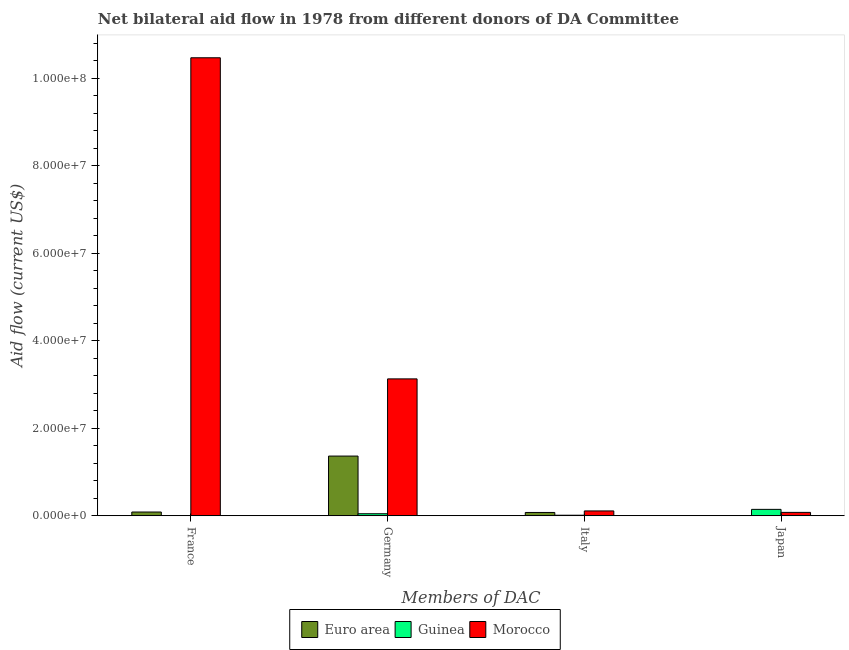How many different coloured bars are there?
Your answer should be very brief. 3. How many groups of bars are there?
Keep it short and to the point. 4. Are the number of bars per tick equal to the number of legend labels?
Make the answer very short. No. How many bars are there on the 2nd tick from the right?
Provide a short and direct response. 3. What is the label of the 3rd group of bars from the left?
Give a very brief answer. Italy. What is the amount of aid given by italy in Morocco?
Keep it short and to the point. 1.11e+06. Across all countries, what is the maximum amount of aid given by japan?
Ensure brevity in your answer.  1.47e+06. Across all countries, what is the minimum amount of aid given by italy?
Ensure brevity in your answer.  1.30e+05. In which country was the amount of aid given by germany maximum?
Offer a very short reply. Morocco. What is the total amount of aid given by italy in the graph?
Keep it short and to the point. 2.00e+06. What is the difference between the amount of aid given by germany in Euro area and that in Guinea?
Your answer should be compact. 1.32e+07. What is the difference between the amount of aid given by germany in Guinea and the amount of aid given by france in Morocco?
Ensure brevity in your answer.  -1.04e+08. What is the average amount of aid given by france per country?
Provide a succinct answer. 3.52e+07. What is the difference between the amount of aid given by italy and amount of aid given by germany in Morocco?
Make the answer very short. -3.02e+07. In how many countries, is the amount of aid given by france greater than 52000000 US$?
Make the answer very short. 1. What is the ratio of the amount of aid given by germany in Guinea to that in Euro area?
Your answer should be compact. 0.03. Is the amount of aid given by germany in Morocco less than that in Guinea?
Give a very brief answer. No. What is the difference between the highest and the second highest amount of aid given by japan?
Your response must be concise. 6.90e+05. What is the difference between the highest and the lowest amount of aid given by japan?
Offer a terse response. 1.44e+06. In how many countries, is the amount of aid given by italy greater than the average amount of aid given by italy taken over all countries?
Offer a very short reply. 2. Is it the case that in every country, the sum of the amount of aid given by france and amount of aid given by germany is greater than the amount of aid given by italy?
Offer a terse response. Yes. Are the values on the major ticks of Y-axis written in scientific E-notation?
Your answer should be very brief. Yes. How many legend labels are there?
Ensure brevity in your answer.  3. How are the legend labels stacked?
Your answer should be very brief. Horizontal. What is the title of the graph?
Your answer should be very brief. Net bilateral aid flow in 1978 from different donors of DA Committee. Does "Uganda" appear as one of the legend labels in the graph?
Your answer should be very brief. No. What is the label or title of the X-axis?
Make the answer very short. Members of DAC. What is the label or title of the Y-axis?
Provide a short and direct response. Aid flow (current US$). What is the Aid flow (current US$) in Euro area in France?
Your response must be concise. 8.60e+05. What is the Aid flow (current US$) in Guinea in France?
Provide a short and direct response. 0. What is the Aid flow (current US$) of Morocco in France?
Keep it short and to the point. 1.05e+08. What is the Aid flow (current US$) in Euro area in Germany?
Provide a short and direct response. 1.36e+07. What is the Aid flow (current US$) of Morocco in Germany?
Make the answer very short. 3.13e+07. What is the Aid flow (current US$) of Euro area in Italy?
Provide a succinct answer. 7.60e+05. What is the Aid flow (current US$) of Morocco in Italy?
Give a very brief answer. 1.11e+06. What is the Aid flow (current US$) in Euro area in Japan?
Offer a very short reply. 3.00e+04. What is the Aid flow (current US$) of Guinea in Japan?
Ensure brevity in your answer.  1.47e+06. What is the Aid flow (current US$) of Morocco in Japan?
Offer a terse response. 7.80e+05. Across all Members of DAC, what is the maximum Aid flow (current US$) of Euro area?
Your answer should be compact. 1.36e+07. Across all Members of DAC, what is the maximum Aid flow (current US$) of Guinea?
Offer a very short reply. 1.47e+06. Across all Members of DAC, what is the maximum Aid flow (current US$) in Morocco?
Provide a short and direct response. 1.05e+08. Across all Members of DAC, what is the minimum Aid flow (current US$) of Morocco?
Make the answer very short. 7.80e+05. What is the total Aid flow (current US$) of Euro area in the graph?
Make the answer very short. 1.53e+07. What is the total Aid flow (current US$) of Guinea in the graph?
Your response must be concise. 2.07e+06. What is the total Aid flow (current US$) in Morocco in the graph?
Provide a succinct answer. 1.38e+08. What is the difference between the Aid flow (current US$) of Euro area in France and that in Germany?
Offer a very short reply. -1.28e+07. What is the difference between the Aid flow (current US$) of Morocco in France and that in Germany?
Keep it short and to the point. 7.34e+07. What is the difference between the Aid flow (current US$) of Euro area in France and that in Italy?
Keep it short and to the point. 1.00e+05. What is the difference between the Aid flow (current US$) of Morocco in France and that in Italy?
Offer a very short reply. 1.04e+08. What is the difference between the Aid flow (current US$) of Euro area in France and that in Japan?
Keep it short and to the point. 8.30e+05. What is the difference between the Aid flow (current US$) in Morocco in France and that in Japan?
Give a very brief answer. 1.04e+08. What is the difference between the Aid flow (current US$) in Euro area in Germany and that in Italy?
Keep it short and to the point. 1.29e+07. What is the difference between the Aid flow (current US$) in Morocco in Germany and that in Italy?
Provide a succinct answer. 3.02e+07. What is the difference between the Aid flow (current US$) of Euro area in Germany and that in Japan?
Your answer should be very brief. 1.36e+07. What is the difference between the Aid flow (current US$) in Morocco in Germany and that in Japan?
Offer a very short reply. 3.05e+07. What is the difference between the Aid flow (current US$) of Euro area in Italy and that in Japan?
Give a very brief answer. 7.30e+05. What is the difference between the Aid flow (current US$) of Guinea in Italy and that in Japan?
Offer a terse response. -1.34e+06. What is the difference between the Aid flow (current US$) of Morocco in Italy and that in Japan?
Ensure brevity in your answer.  3.30e+05. What is the difference between the Aid flow (current US$) of Euro area in France and the Aid flow (current US$) of Morocco in Germany?
Ensure brevity in your answer.  -3.04e+07. What is the difference between the Aid flow (current US$) of Euro area in France and the Aid flow (current US$) of Guinea in Italy?
Your response must be concise. 7.30e+05. What is the difference between the Aid flow (current US$) of Euro area in France and the Aid flow (current US$) of Morocco in Italy?
Give a very brief answer. -2.50e+05. What is the difference between the Aid flow (current US$) of Euro area in France and the Aid flow (current US$) of Guinea in Japan?
Offer a terse response. -6.10e+05. What is the difference between the Aid flow (current US$) of Euro area in Germany and the Aid flow (current US$) of Guinea in Italy?
Keep it short and to the point. 1.35e+07. What is the difference between the Aid flow (current US$) in Euro area in Germany and the Aid flow (current US$) in Morocco in Italy?
Your response must be concise. 1.25e+07. What is the difference between the Aid flow (current US$) of Guinea in Germany and the Aid flow (current US$) of Morocco in Italy?
Offer a very short reply. -6.40e+05. What is the difference between the Aid flow (current US$) in Euro area in Germany and the Aid flow (current US$) in Guinea in Japan?
Make the answer very short. 1.22e+07. What is the difference between the Aid flow (current US$) in Euro area in Germany and the Aid flow (current US$) in Morocco in Japan?
Keep it short and to the point. 1.29e+07. What is the difference between the Aid flow (current US$) in Guinea in Germany and the Aid flow (current US$) in Morocco in Japan?
Keep it short and to the point. -3.10e+05. What is the difference between the Aid flow (current US$) in Euro area in Italy and the Aid flow (current US$) in Guinea in Japan?
Offer a very short reply. -7.10e+05. What is the difference between the Aid flow (current US$) in Guinea in Italy and the Aid flow (current US$) in Morocco in Japan?
Offer a very short reply. -6.50e+05. What is the average Aid flow (current US$) in Euro area per Members of DAC?
Your response must be concise. 3.82e+06. What is the average Aid flow (current US$) in Guinea per Members of DAC?
Provide a short and direct response. 5.18e+05. What is the average Aid flow (current US$) in Morocco per Members of DAC?
Offer a terse response. 3.45e+07. What is the difference between the Aid flow (current US$) in Euro area and Aid flow (current US$) in Morocco in France?
Ensure brevity in your answer.  -1.04e+08. What is the difference between the Aid flow (current US$) of Euro area and Aid flow (current US$) of Guinea in Germany?
Give a very brief answer. 1.32e+07. What is the difference between the Aid flow (current US$) of Euro area and Aid flow (current US$) of Morocco in Germany?
Keep it short and to the point. -1.76e+07. What is the difference between the Aid flow (current US$) of Guinea and Aid flow (current US$) of Morocco in Germany?
Make the answer very short. -3.08e+07. What is the difference between the Aid flow (current US$) of Euro area and Aid flow (current US$) of Guinea in Italy?
Provide a short and direct response. 6.30e+05. What is the difference between the Aid flow (current US$) in Euro area and Aid flow (current US$) in Morocco in Italy?
Provide a short and direct response. -3.50e+05. What is the difference between the Aid flow (current US$) of Guinea and Aid flow (current US$) of Morocco in Italy?
Your answer should be compact. -9.80e+05. What is the difference between the Aid flow (current US$) of Euro area and Aid flow (current US$) of Guinea in Japan?
Your answer should be compact. -1.44e+06. What is the difference between the Aid flow (current US$) of Euro area and Aid flow (current US$) of Morocco in Japan?
Keep it short and to the point. -7.50e+05. What is the difference between the Aid flow (current US$) of Guinea and Aid flow (current US$) of Morocco in Japan?
Provide a short and direct response. 6.90e+05. What is the ratio of the Aid flow (current US$) of Euro area in France to that in Germany?
Give a very brief answer. 0.06. What is the ratio of the Aid flow (current US$) in Morocco in France to that in Germany?
Offer a terse response. 3.35. What is the ratio of the Aid flow (current US$) of Euro area in France to that in Italy?
Give a very brief answer. 1.13. What is the ratio of the Aid flow (current US$) of Morocco in France to that in Italy?
Ensure brevity in your answer.  94.31. What is the ratio of the Aid flow (current US$) in Euro area in France to that in Japan?
Keep it short and to the point. 28.67. What is the ratio of the Aid flow (current US$) in Morocco in France to that in Japan?
Offer a terse response. 134.21. What is the ratio of the Aid flow (current US$) in Euro area in Germany to that in Italy?
Give a very brief answer. 17.96. What is the ratio of the Aid flow (current US$) of Guinea in Germany to that in Italy?
Your answer should be very brief. 3.62. What is the ratio of the Aid flow (current US$) of Morocco in Germany to that in Italy?
Provide a short and direct response. 28.19. What is the ratio of the Aid flow (current US$) in Euro area in Germany to that in Japan?
Give a very brief answer. 455. What is the ratio of the Aid flow (current US$) in Guinea in Germany to that in Japan?
Your answer should be compact. 0.32. What is the ratio of the Aid flow (current US$) of Morocco in Germany to that in Japan?
Your answer should be very brief. 40.12. What is the ratio of the Aid flow (current US$) in Euro area in Italy to that in Japan?
Give a very brief answer. 25.33. What is the ratio of the Aid flow (current US$) of Guinea in Italy to that in Japan?
Provide a succinct answer. 0.09. What is the ratio of the Aid flow (current US$) of Morocco in Italy to that in Japan?
Keep it short and to the point. 1.42. What is the difference between the highest and the second highest Aid flow (current US$) of Euro area?
Provide a succinct answer. 1.28e+07. What is the difference between the highest and the second highest Aid flow (current US$) of Morocco?
Your answer should be compact. 7.34e+07. What is the difference between the highest and the lowest Aid flow (current US$) of Euro area?
Offer a very short reply. 1.36e+07. What is the difference between the highest and the lowest Aid flow (current US$) in Guinea?
Offer a very short reply. 1.47e+06. What is the difference between the highest and the lowest Aid flow (current US$) in Morocco?
Offer a terse response. 1.04e+08. 